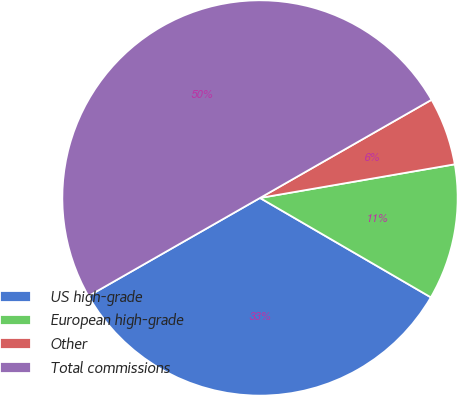Convert chart. <chart><loc_0><loc_0><loc_500><loc_500><pie_chart><fcel>US high-grade<fcel>European high-grade<fcel>Other<fcel>Total commissions<nl><fcel>33.35%<fcel>11.11%<fcel>5.55%<fcel>50.0%<nl></chart> 